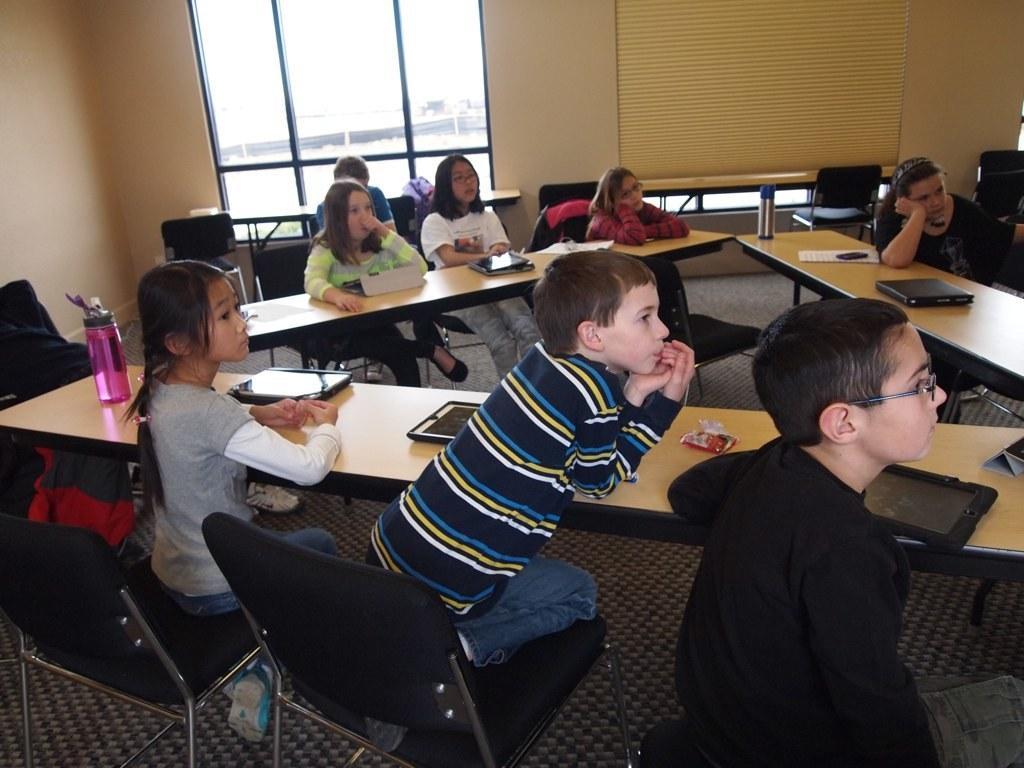In one or two sentences, can you explain what this image depicts? In this image there are group of people sitting in chair , and in table there is bottle, Ipads , laptop, there is carpet and the back ground there is a window. 